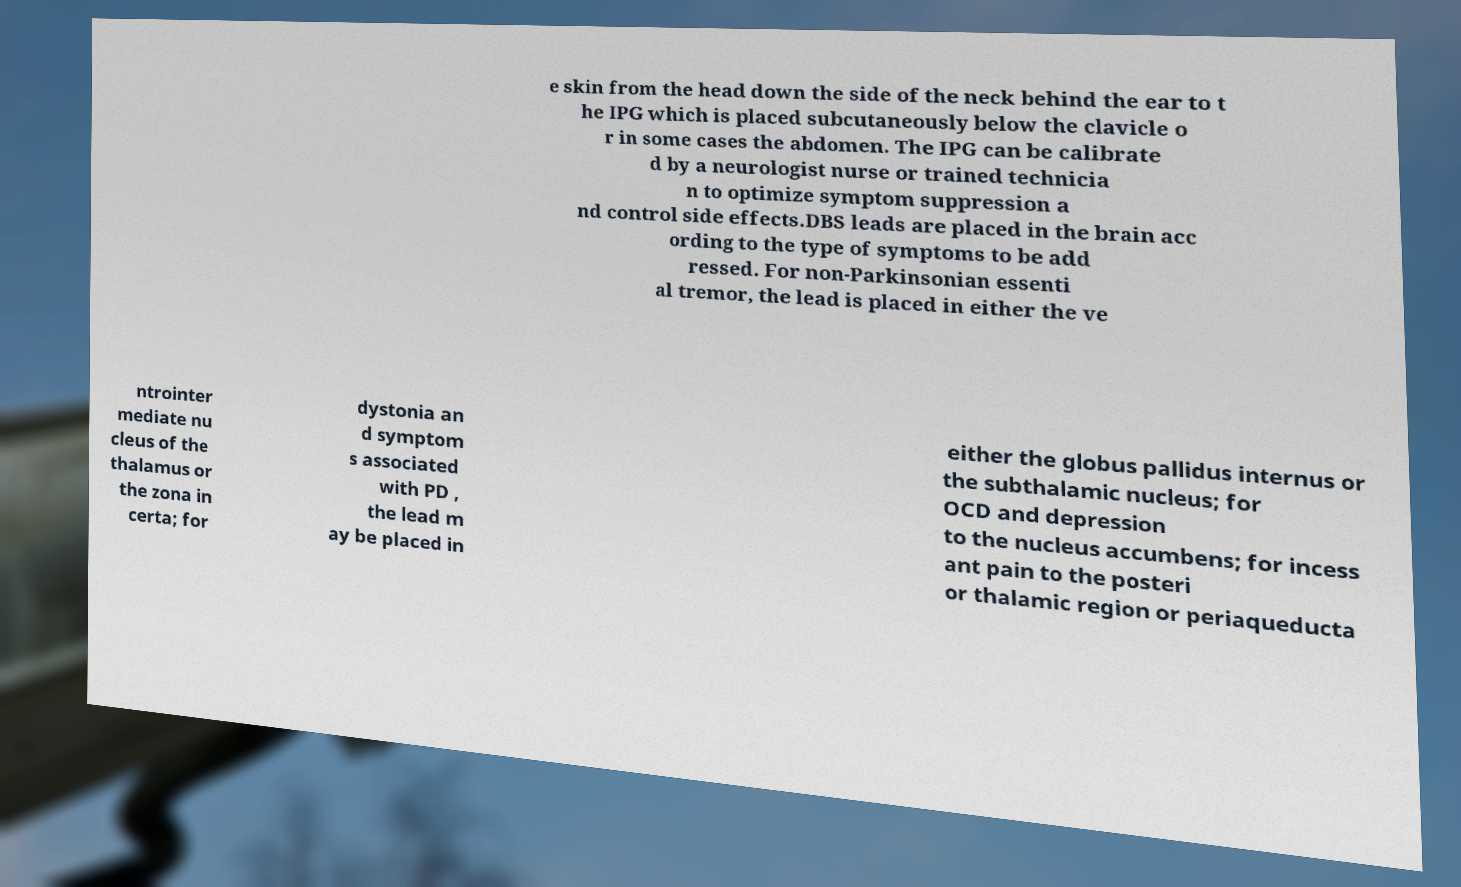Could you extract and type out the text from this image? e skin from the head down the side of the neck behind the ear to t he IPG which is placed subcutaneously below the clavicle o r in some cases the abdomen. The IPG can be calibrate d by a neurologist nurse or trained technicia n to optimize symptom suppression a nd control side effects.DBS leads are placed in the brain acc ording to the type of symptoms to be add ressed. For non-Parkinsonian essenti al tremor, the lead is placed in either the ve ntrointer mediate nu cleus of the thalamus or the zona in certa; for dystonia an d symptom s associated with PD , the lead m ay be placed in either the globus pallidus internus or the subthalamic nucleus; for OCD and depression to the nucleus accumbens; for incess ant pain to the posteri or thalamic region or periaqueducta 